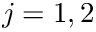Convert formula to latex. <formula><loc_0><loc_0><loc_500><loc_500>j = 1 , 2</formula> 